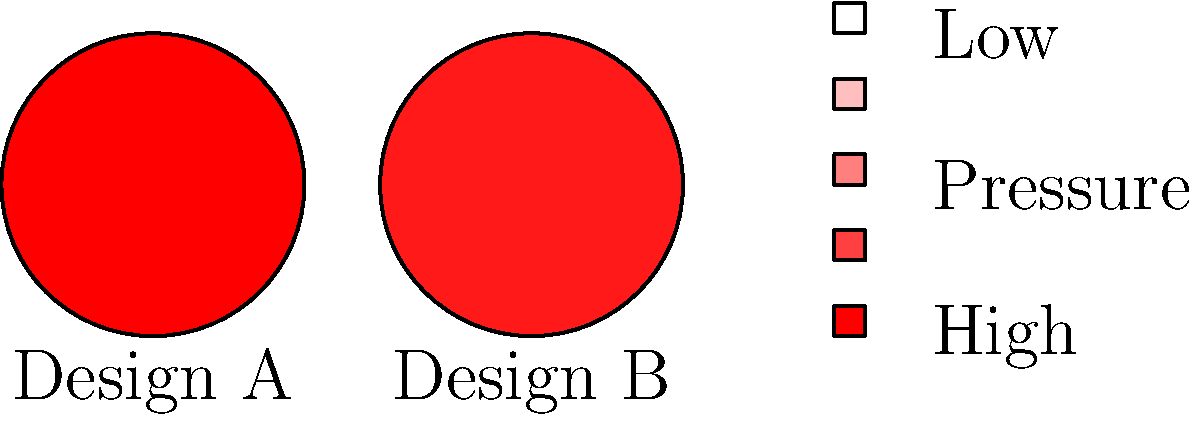Based on the pressure maps shown for two prosthetic foot designs, which design is likely to provide better force distribution and potentially reduce the risk of pressure ulcers in patients with lower limb amputations? To determine which prosthetic foot design provides better force distribution, we need to analyze the pressure maps:

1. Interpret the color scale:
   - Red indicates high pressure
   - White indicates low pressure

2. Analyze Design A:
   - The center area shows intense red, indicating very high pressure
   - The pressure decreases rapidly towards the edges

3. Analyze Design B:
   - The pressure distribution is more gradual from the center to the edges
   - There is less intense red in the center, suggesting lower peak pressure

4. Compare the designs:
   - Design B shows a more even distribution of pressure across the foot
   - Design A has a concentrated high-pressure area, which could lead to discomfort or pressure ulcers

5. Consider the implications:
   - Even pressure distribution reduces the risk of pressure points
   - Lower peak pressures decrease the likelihood of tissue damage

6. Relate to patient care:
   - Reduced risk of pressure ulcers leads to better outcomes for patients
   - More even pressure distribution can improve comfort and mobility

Therefore, Design B is likely to provide better force distribution and potentially reduce the risk of pressure ulcers in patients with lower limb amputations.
Answer: Design B 